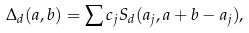<formula> <loc_0><loc_0><loc_500><loc_500>\Delta _ { d } ( a , b ) & = \sum c _ { j } S _ { d } ( a _ { j } , a + b - a _ { j } ) ,</formula> 